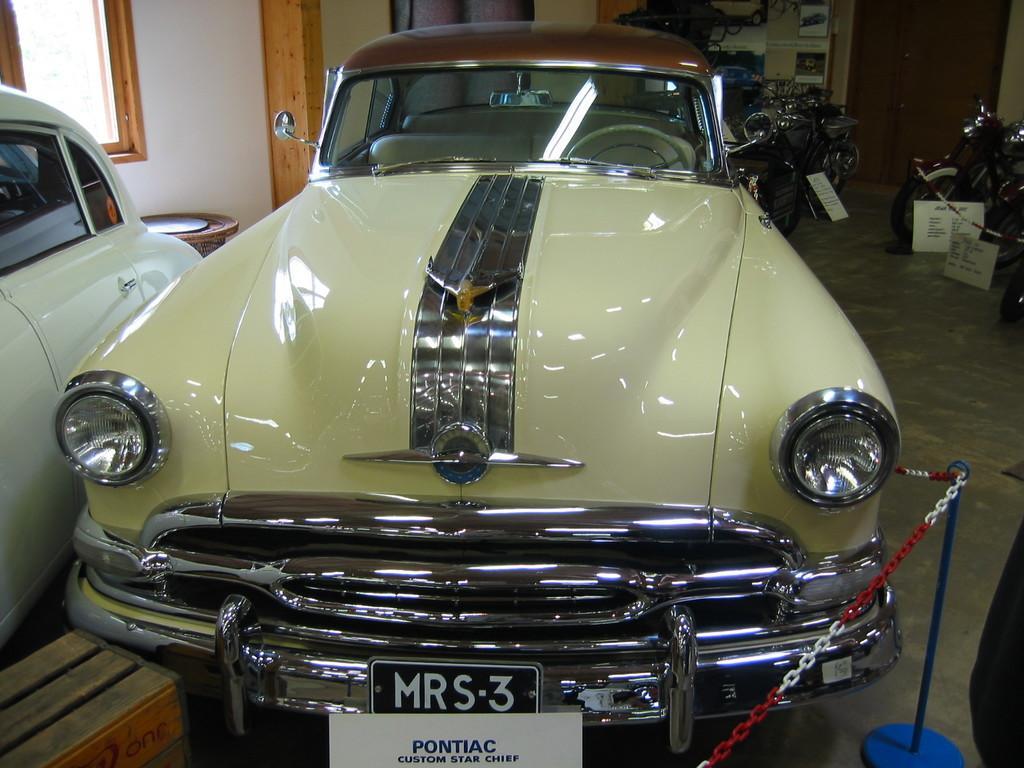In one or two sentences, can you explain what this image depicts? In this image I can see the floor, few cars and few motorbikes on the floor, the metal chain to the blue colored pole, few white colored boards and in the background I can see the wall, the window, the door and few other objects. 